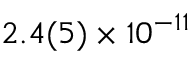<formula> <loc_0><loc_0><loc_500><loc_500>2 . 4 ( 5 ) \times 1 0 ^ { - 1 1 }</formula> 